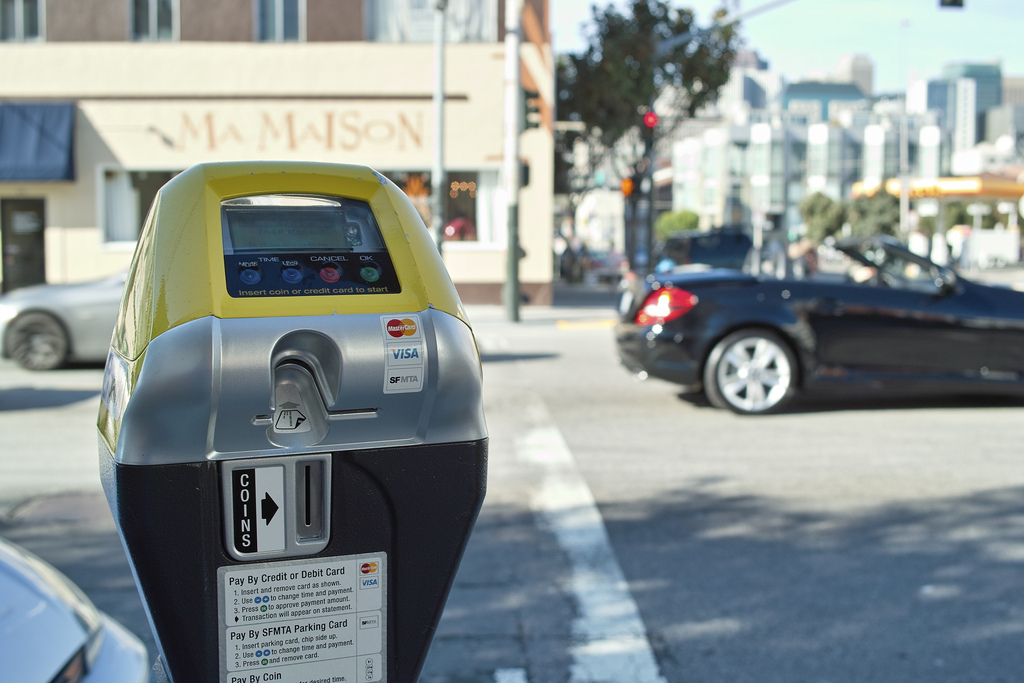Is the color of the vehicle different than the color of the parking meter? No, the color of the vehicle and the color of the parking meter are not different. 